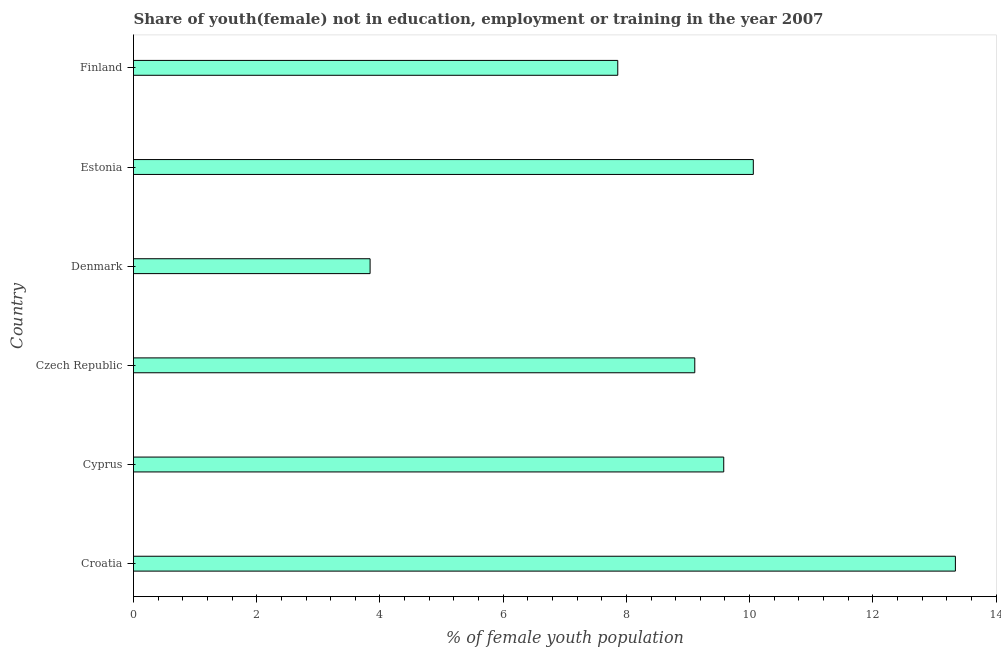What is the title of the graph?
Offer a very short reply. Share of youth(female) not in education, employment or training in the year 2007. What is the label or title of the X-axis?
Your response must be concise. % of female youth population. What is the label or title of the Y-axis?
Your response must be concise. Country. What is the unemployed female youth population in Estonia?
Offer a terse response. 10.06. Across all countries, what is the maximum unemployed female youth population?
Keep it short and to the point. 13.34. Across all countries, what is the minimum unemployed female youth population?
Make the answer very short. 3.84. In which country was the unemployed female youth population maximum?
Your answer should be compact. Croatia. In which country was the unemployed female youth population minimum?
Provide a short and direct response. Denmark. What is the sum of the unemployed female youth population?
Your response must be concise. 53.79. What is the difference between the unemployed female youth population in Czech Republic and Finland?
Give a very brief answer. 1.25. What is the average unemployed female youth population per country?
Your answer should be very brief. 8.96. What is the median unemployed female youth population?
Your answer should be compact. 9.34. In how many countries, is the unemployed female youth population greater than 9.6 %?
Make the answer very short. 2. What is the ratio of the unemployed female youth population in Croatia to that in Estonia?
Your response must be concise. 1.33. Is the unemployed female youth population in Cyprus less than that in Denmark?
Ensure brevity in your answer.  No. What is the difference between the highest and the second highest unemployed female youth population?
Keep it short and to the point. 3.28. Is the sum of the unemployed female youth population in Denmark and Estonia greater than the maximum unemployed female youth population across all countries?
Give a very brief answer. Yes. In how many countries, is the unemployed female youth population greater than the average unemployed female youth population taken over all countries?
Make the answer very short. 4. How many bars are there?
Give a very brief answer. 6. Are the values on the major ticks of X-axis written in scientific E-notation?
Your answer should be very brief. No. What is the % of female youth population in Croatia?
Provide a short and direct response. 13.34. What is the % of female youth population in Cyprus?
Offer a very short reply. 9.58. What is the % of female youth population of Czech Republic?
Ensure brevity in your answer.  9.11. What is the % of female youth population of Denmark?
Your response must be concise. 3.84. What is the % of female youth population of Estonia?
Your answer should be very brief. 10.06. What is the % of female youth population of Finland?
Provide a short and direct response. 7.86. What is the difference between the % of female youth population in Croatia and Cyprus?
Offer a very short reply. 3.76. What is the difference between the % of female youth population in Croatia and Czech Republic?
Your answer should be compact. 4.23. What is the difference between the % of female youth population in Croatia and Denmark?
Make the answer very short. 9.5. What is the difference between the % of female youth population in Croatia and Estonia?
Provide a succinct answer. 3.28. What is the difference between the % of female youth population in Croatia and Finland?
Offer a very short reply. 5.48. What is the difference between the % of female youth population in Cyprus and Czech Republic?
Offer a terse response. 0.47. What is the difference between the % of female youth population in Cyprus and Denmark?
Give a very brief answer. 5.74. What is the difference between the % of female youth population in Cyprus and Estonia?
Your answer should be compact. -0.48. What is the difference between the % of female youth population in Cyprus and Finland?
Provide a succinct answer. 1.72. What is the difference between the % of female youth population in Czech Republic and Denmark?
Your response must be concise. 5.27. What is the difference between the % of female youth population in Czech Republic and Estonia?
Provide a succinct answer. -0.95. What is the difference between the % of female youth population in Denmark and Estonia?
Offer a terse response. -6.22. What is the difference between the % of female youth population in Denmark and Finland?
Your response must be concise. -4.02. What is the difference between the % of female youth population in Estonia and Finland?
Your response must be concise. 2.2. What is the ratio of the % of female youth population in Croatia to that in Cyprus?
Your answer should be compact. 1.39. What is the ratio of the % of female youth population in Croatia to that in Czech Republic?
Offer a very short reply. 1.46. What is the ratio of the % of female youth population in Croatia to that in Denmark?
Offer a very short reply. 3.47. What is the ratio of the % of female youth population in Croatia to that in Estonia?
Your response must be concise. 1.33. What is the ratio of the % of female youth population in Croatia to that in Finland?
Make the answer very short. 1.7. What is the ratio of the % of female youth population in Cyprus to that in Czech Republic?
Ensure brevity in your answer.  1.05. What is the ratio of the % of female youth population in Cyprus to that in Denmark?
Provide a short and direct response. 2.5. What is the ratio of the % of female youth population in Cyprus to that in Finland?
Offer a terse response. 1.22. What is the ratio of the % of female youth population in Czech Republic to that in Denmark?
Ensure brevity in your answer.  2.37. What is the ratio of the % of female youth population in Czech Republic to that in Estonia?
Your answer should be compact. 0.91. What is the ratio of the % of female youth population in Czech Republic to that in Finland?
Make the answer very short. 1.16. What is the ratio of the % of female youth population in Denmark to that in Estonia?
Your answer should be compact. 0.38. What is the ratio of the % of female youth population in Denmark to that in Finland?
Offer a terse response. 0.49. What is the ratio of the % of female youth population in Estonia to that in Finland?
Provide a short and direct response. 1.28. 